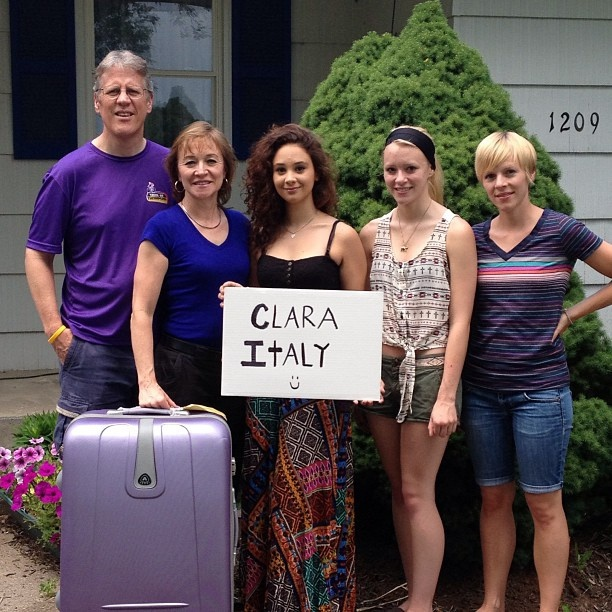Describe the objects in this image and their specific colors. I can see people in black, maroon, brown, and gray tones, people in black, brown, navy, and maroon tones, people in black, gray, lightgray, and tan tones, suitcase in black, purple, gray, and lavender tones, and people in black, navy, and purple tones in this image. 